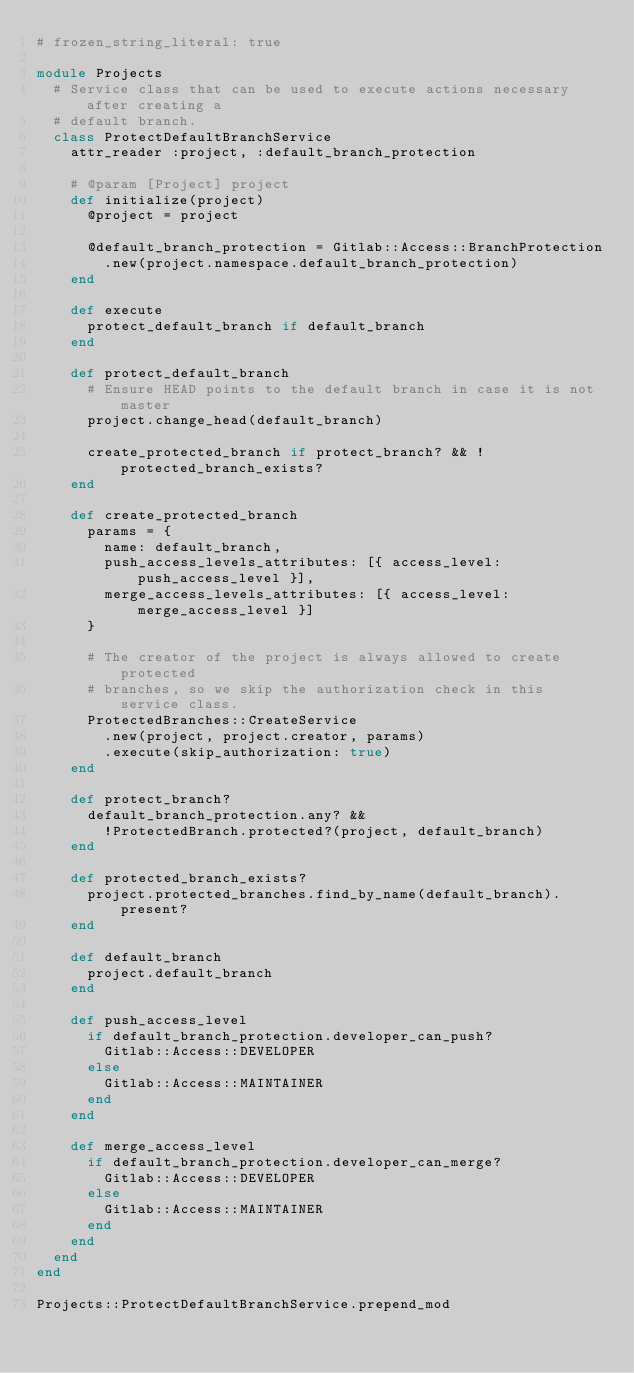Convert code to text. <code><loc_0><loc_0><loc_500><loc_500><_Ruby_># frozen_string_literal: true

module Projects
  # Service class that can be used to execute actions necessary after creating a
  # default branch.
  class ProtectDefaultBranchService
    attr_reader :project, :default_branch_protection

    # @param [Project] project
    def initialize(project)
      @project = project

      @default_branch_protection = Gitlab::Access::BranchProtection
        .new(project.namespace.default_branch_protection)
    end

    def execute
      protect_default_branch if default_branch
    end

    def protect_default_branch
      # Ensure HEAD points to the default branch in case it is not master
      project.change_head(default_branch)

      create_protected_branch if protect_branch? && !protected_branch_exists?
    end

    def create_protected_branch
      params = {
        name: default_branch,
        push_access_levels_attributes: [{ access_level: push_access_level }],
        merge_access_levels_attributes: [{ access_level: merge_access_level }]
      }

      # The creator of the project is always allowed to create protected
      # branches, so we skip the authorization check in this service class.
      ProtectedBranches::CreateService
        .new(project, project.creator, params)
        .execute(skip_authorization: true)
    end

    def protect_branch?
      default_branch_protection.any? &&
        !ProtectedBranch.protected?(project, default_branch)
    end

    def protected_branch_exists?
      project.protected_branches.find_by_name(default_branch).present?
    end

    def default_branch
      project.default_branch
    end

    def push_access_level
      if default_branch_protection.developer_can_push?
        Gitlab::Access::DEVELOPER
      else
        Gitlab::Access::MAINTAINER
      end
    end

    def merge_access_level
      if default_branch_protection.developer_can_merge?
        Gitlab::Access::DEVELOPER
      else
        Gitlab::Access::MAINTAINER
      end
    end
  end
end

Projects::ProtectDefaultBranchService.prepend_mod
</code> 